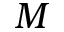Convert formula to latex. <formula><loc_0><loc_0><loc_500><loc_500>M</formula> 